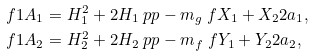<formula> <loc_0><loc_0><loc_500><loc_500>\ f { 1 } { A _ { 1 } } & = H _ { 1 } ^ { 2 } + 2 H _ { 1 } \ p p - m _ { g } \ f { X _ { 1 } + X _ { 2 } } { 2 a _ { 1 } } , \\ \ f { 1 } { A _ { 2 } } & = H _ { 2 } ^ { 2 } + 2 H _ { 2 } \ p p - m _ { f } \ f { Y _ { 1 } + Y _ { 2 } } { 2 a _ { 2 } } ,</formula> 